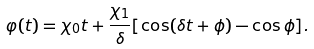<formula> <loc_0><loc_0><loc_500><loc_500>\varphi ( t ) = \chi _ { 0 } t + \frac { \chi _ { 1 } } { \delta } [ \cos ( \delta t + \phi ) - \cos \phi ] .</formula> 